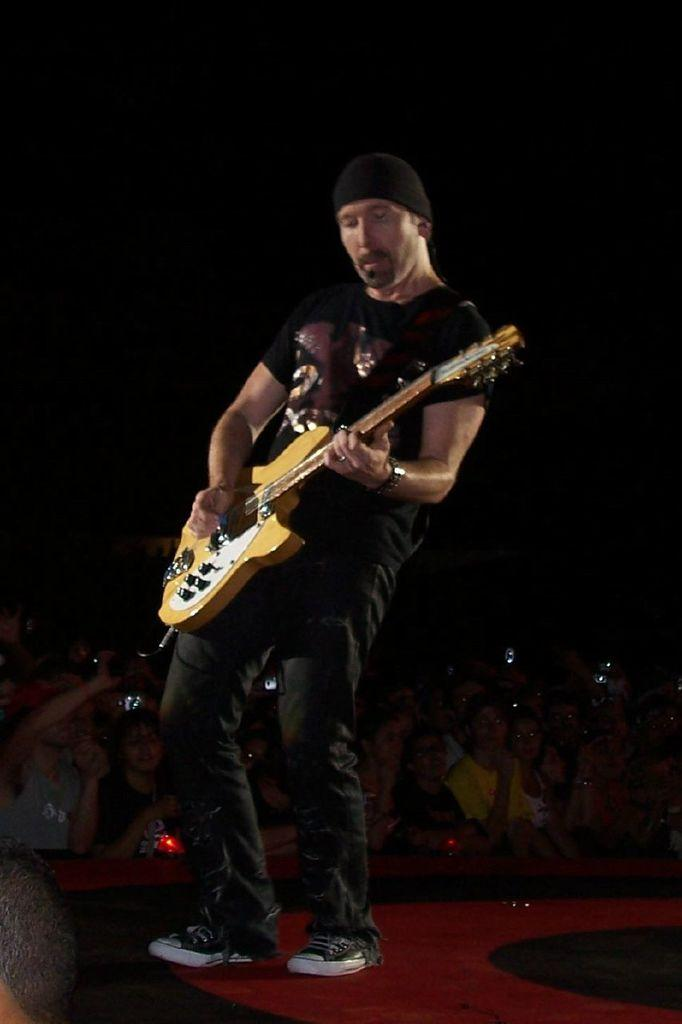What is the man on the stage doing? The man is playing a guitar. What might be the man's purpose on the stage? The man is likely performing music for the people in the background. How are the people in the background reacting to the man's performance? The people in the background are enjoying the music. What type of bell can be heard ringing in the background of the image? There is no bell ringing in the background of the image; it only features a man playing a guitar and people enjoying the music. 